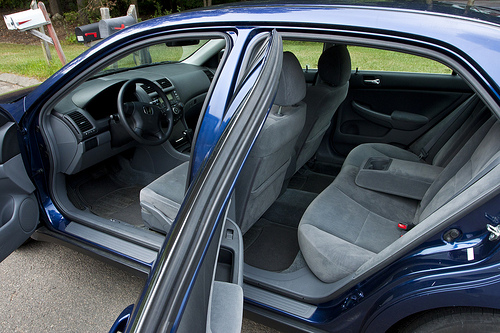<image>
Can you confirm if the car is in front of the seat? No. The car is not in front of the seat. The spatial positioning shows a different relationship between these objects. 